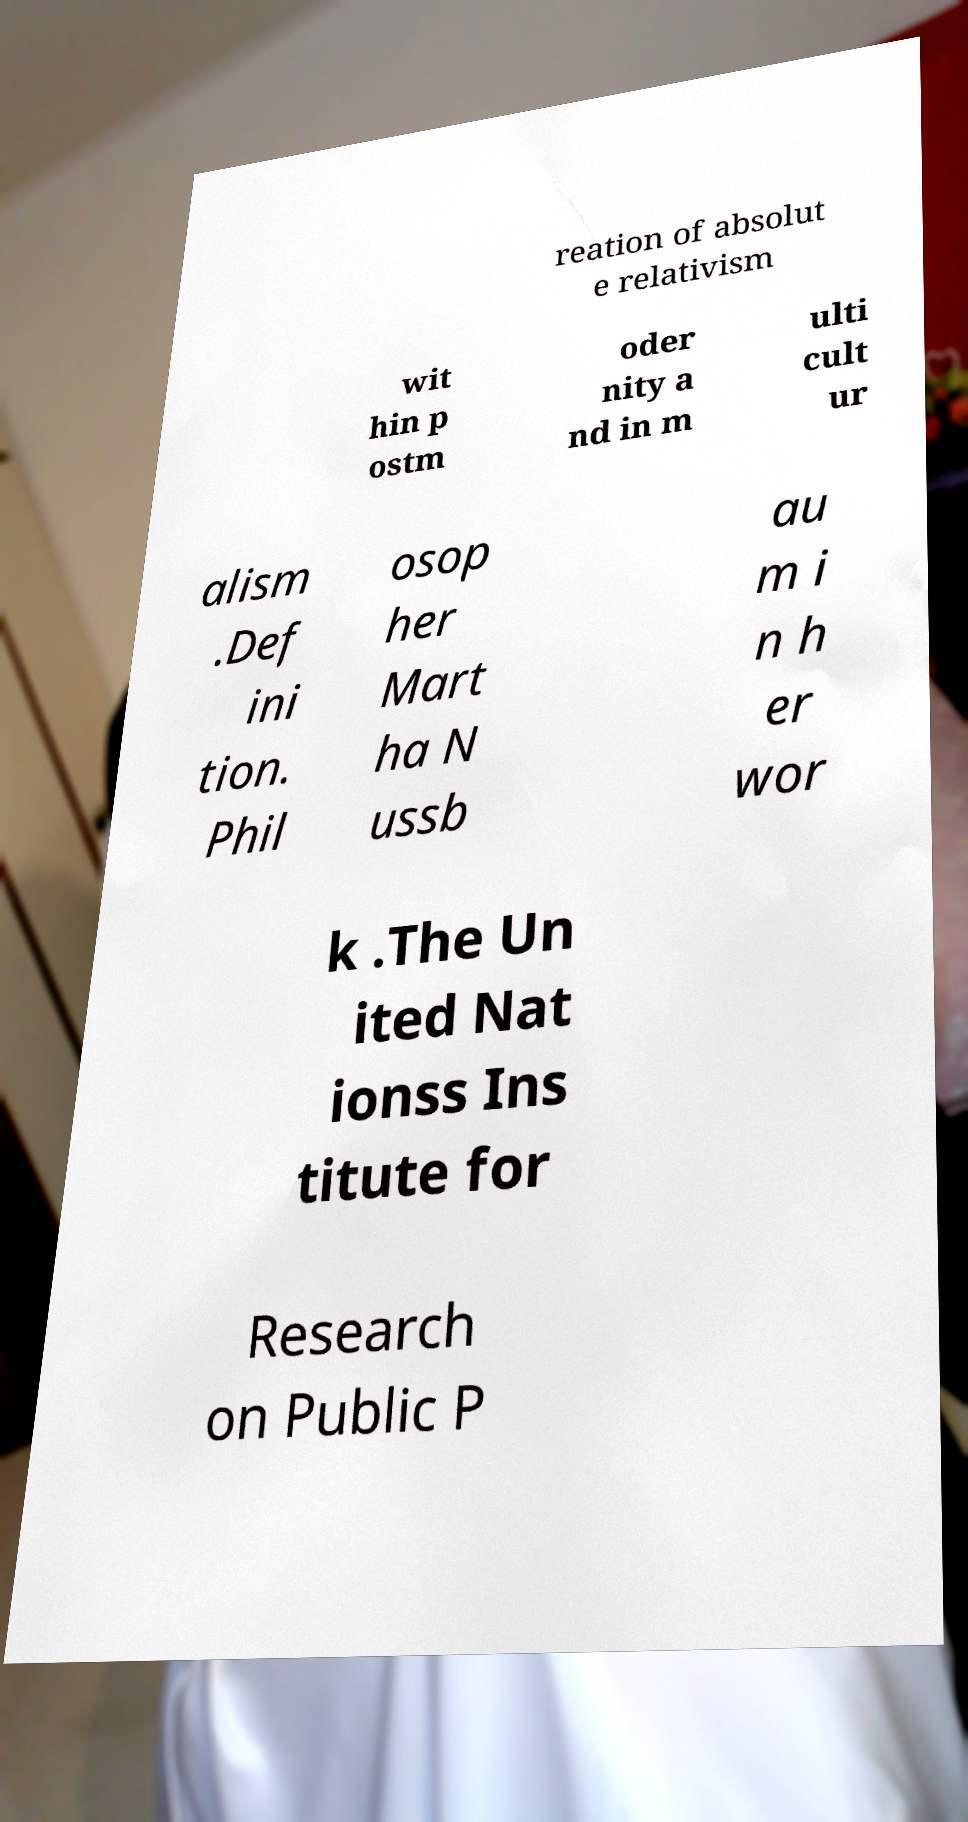Could you assist in decoding the text presented in this image and type it out clearly? reation of absolut e relativism wit hin p ostm oder nity a nd in m ulti cult ur alism .Def ini tion. Phil osop her Mart ha N ussb au m i n h er wor k .The Un ited Nat ionss Ins titute for Research on Public P 